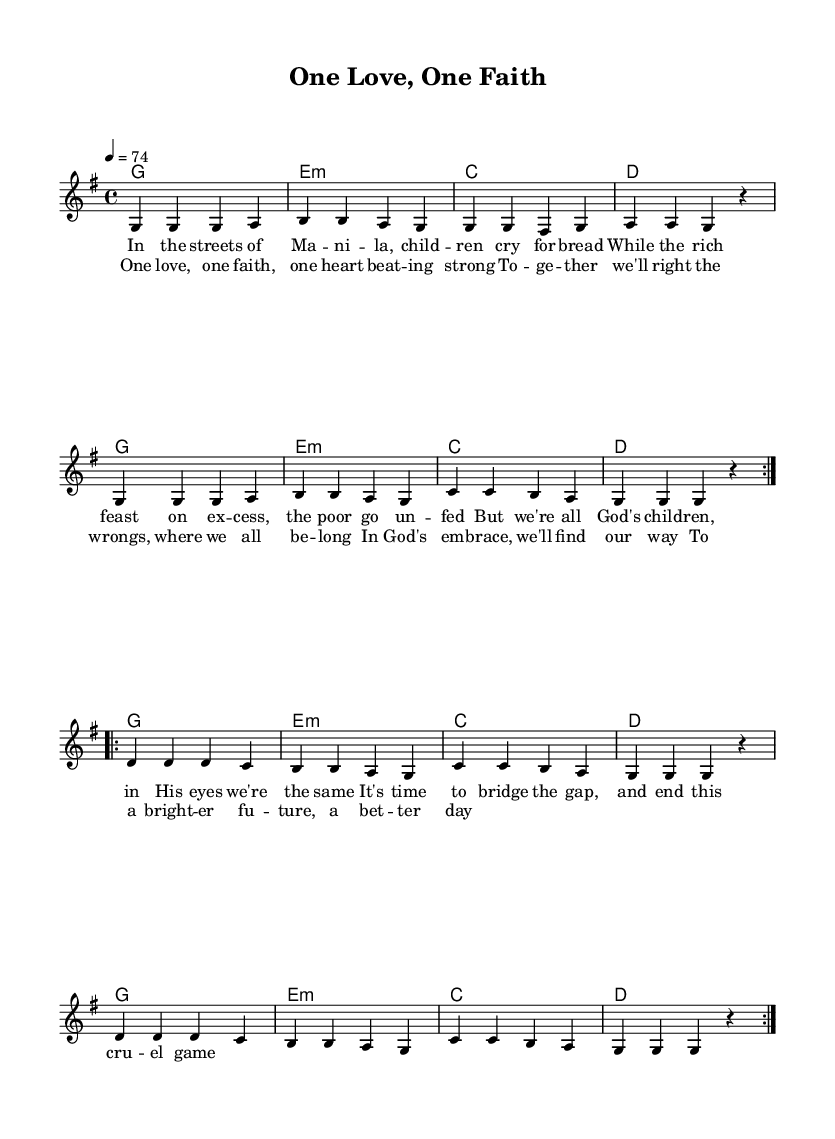What is the key signature of this music? The key signature is G major, which has one sharp (F#). This can be identified by looking at the beginning of the music sheet where the key signature is notated.
Answer: G major What is the time signature of this music? The time signature is 4/4, indicating that there are four beats in a measure, and the quarter note gets one beat. This is shown at the beginning of the sheet music.
Answer: 4/4 What is the tempo marking for this piece? The tempo marking is "4 = 74", meaning there are 74 beats per minute, with the quarter note given a value of 4. This information is typically found right after the time signature at the start of the score.
Answer: 74 How many times is the chorus repeated in this piece? The chorus is repeated twice, which can be inferred from the lyrics section where the chorus is labeled and indicated for repetition.
Answer: 2 What is the main theme addressed in the lyrics of the song? The main theme addressed in the lyrics focuses on social issues and unity, particularly the disparity between the rich and poor and a call for collective action. This theme can be inferred from the content of the lyrics provided in the sheet music.
Answer: Social issues What are the primary chords used in the harmonies? The primary chords used in the harmonies are G, E minor, C, and D, as seen in the chord progression indicated at the beginning of the score.
Answer: G, E minor, C, D What is the structure of the song demonstrated in the music? The structure of the song follows a verse-chorus format, with the verses addressing the social issues followed by the chorus emphasizing unity. This can be identified by the label "verse" and "chorus" in the lyrics.
Answer: Verse-chorus 